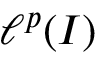Convert formula to latex. <formula><loc_0><loc_0><loc_500><loc_500>\ell ^ { p } ( I )</formula> 